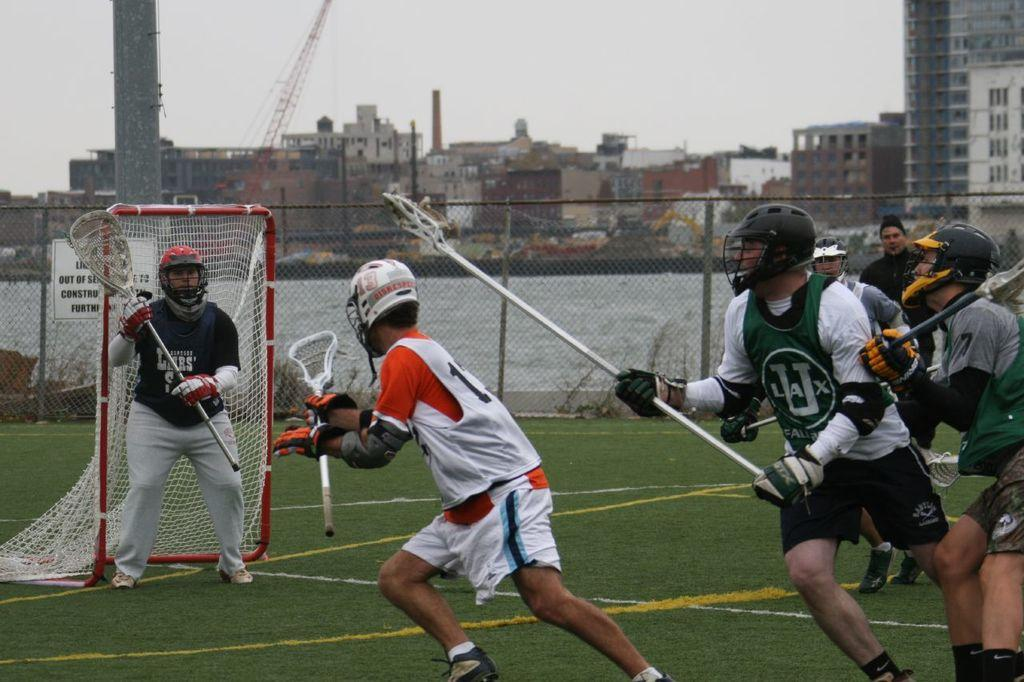<image>
Share a concise interpretation of the image provided. LaCrosse players are on a field with a sign behind them that informs of construction. 